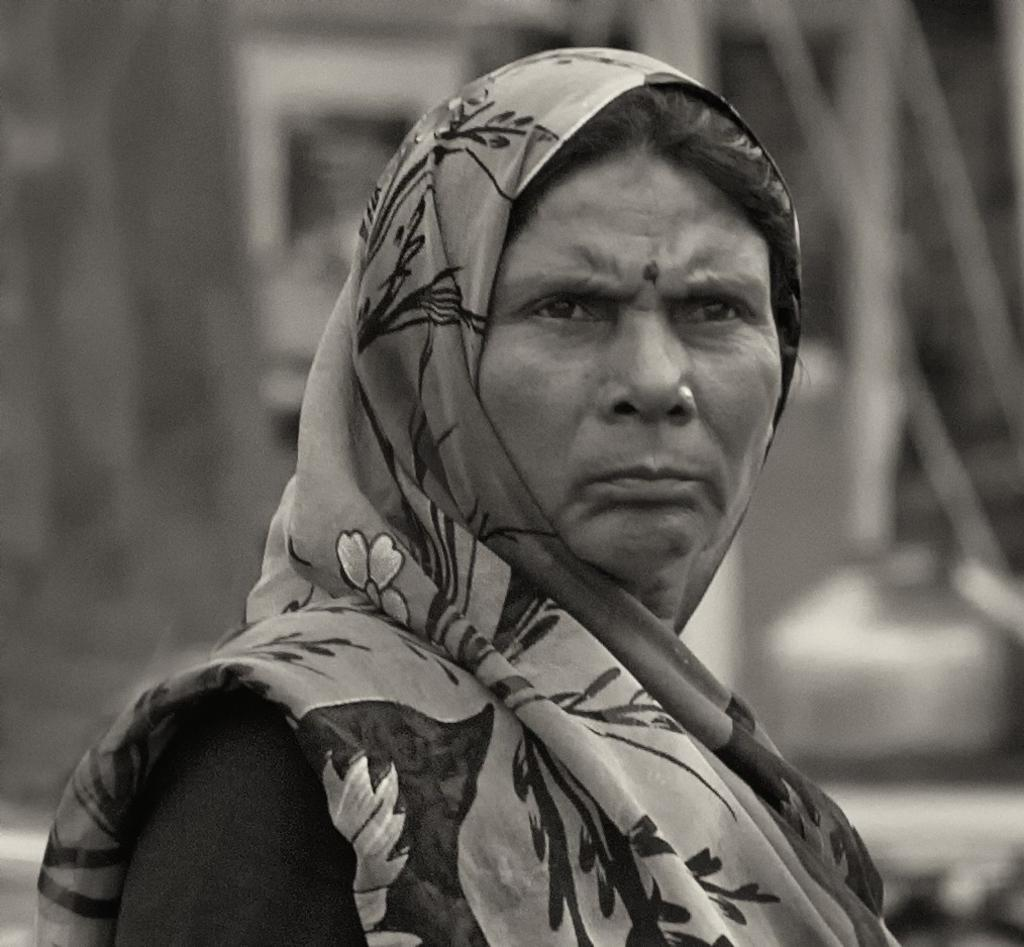What is the color scheme of the image? The image is black and white. Who is the main subject in the image? There is a lady in the center of the image. What is the lady wearing? The lady is wearing a saree. What type of joke is being told by the lady in the image? There is no indication of a joke being told in the image, as it only features a lady wearing a saree. Can you see a church in the background of the image? There is no church visible in the image; it only features a lady wearing a saree. 